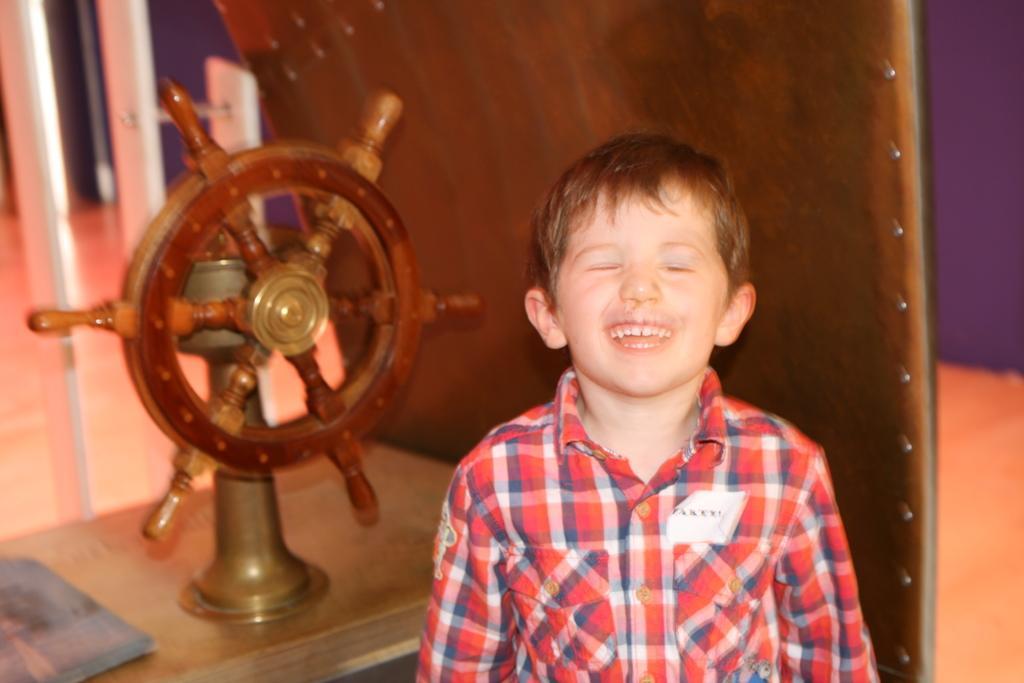Can you describe this image briefly? This picture shows a boy and we see a wheel on the table. 